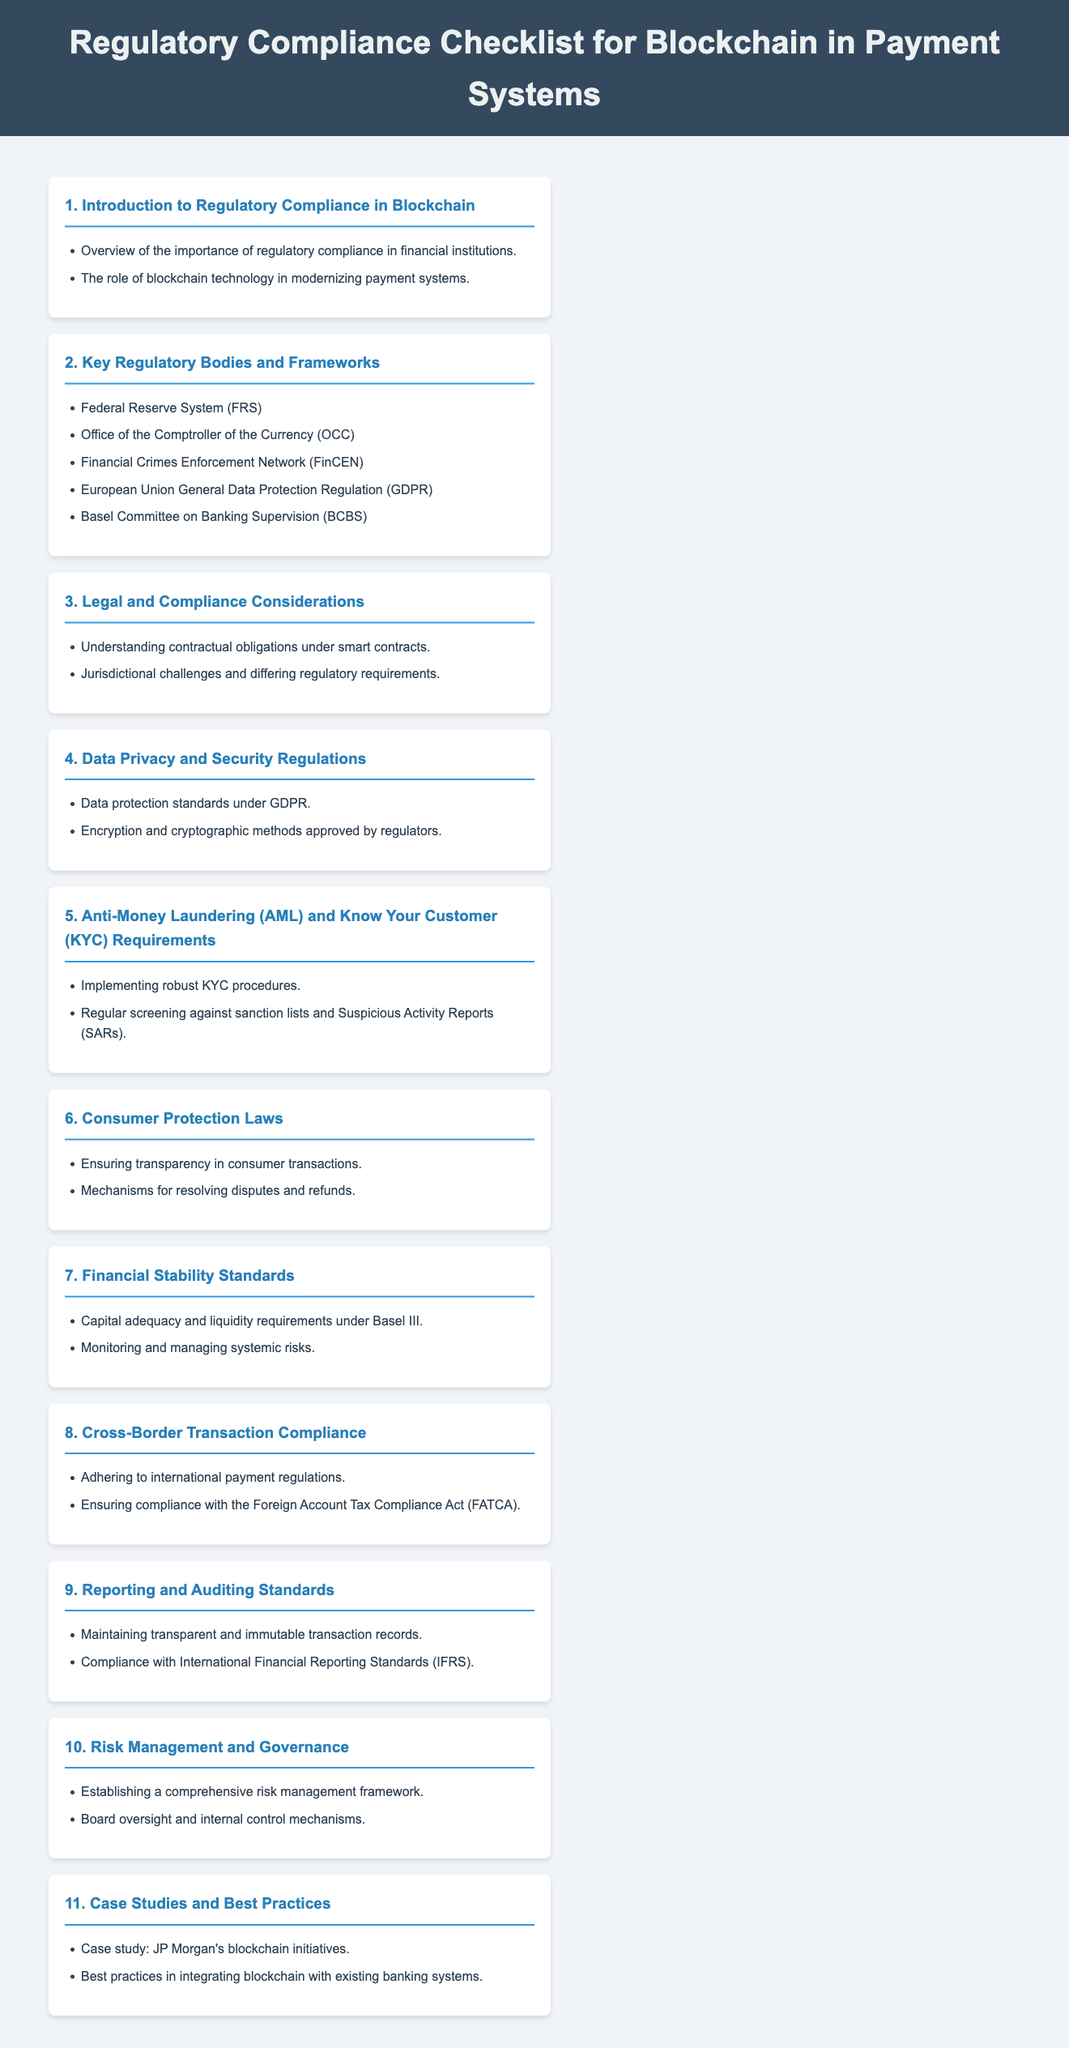What is the title of the document? The title of the document is presented in the header section and summarizes its content regarding regulatory compliance in blockchain.
Answer: Regulatory Compliance Checklist for Blockchain in Payment Systems How many key regulatory bodies are listed? The section titled "Key Regulatory Bodies and Frameworks" mentions a total of five regulatory bodies, indicating the extent of oversight required for compliance.
Answer: 5 What is one of the anti-money laundering requirements? In the section on AML and KYC Requirements, implementing robust KYC procedures is highlighted as a crucial step towards compliance.
Answer: Robust KYC procedures Which regulation is mentioned under data privacy? The section on Data Privacy and Security Regulations specifically references GDPR as a critical framework for data protection in financial systems.
Answer: GDPR What is a content focus of the "Consumer Protection Laws" section? The "Consumer Protection Laws" section emphasizes the need for transparency in consumer transactions, showcasing a commitment to protecting customer rights.
Answer: Transparency in consumer transactions What is one case study mentioned in the document? The section titled "Case Studies and Best Practices" includes a reference to JP Morgan's blockchain initiatives as a significant example in the industry.
Answer: JP Morgan's blockchain initiatives What does the section on financial stability emphasize? In the "Financial Stability Standards" section, the emphasis is on capital adequacy and liquidity requirements, which are essential for maintaining the stability of financial institutions.
Answer: Capital adequacy and liquidity requirements Which act is important for cross-border compliance? The "Cross-Border Transaction Compliance" section states that adherence to the Foreign Account Tax Compliance Act (FATCA) is crucial for international transactions.
Answer: FATCA What is a key requirement for reporting? The "Reporting and Auditing Standards" section indicates that maintaining transparent and immutable transaction records is a key requirement for regulatory compliance.
Answer: Transparent and immutable transaction records 